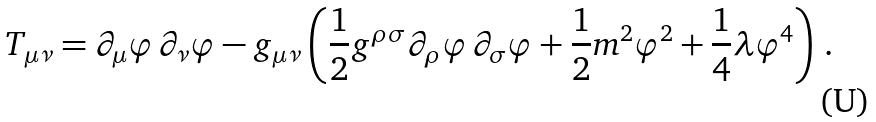<formula> <loc_0><loc_0><loc_500><loc_500>T _ { \mu \nu } = \partial _ { \mu } \varphi \, \partial _ { \nu } \varphi - g _ { \mu \nu } \left ( \frac { 1 } { 2 } g ^ { \rho \sigma } \partial _ { \rho } \varphi \, \partial _ { \sigma } \varphi + \frac { 1 } { 2 } m ^ { 2 } \varphi ^ { 2 } + \frac { 1 } { 4 } \lambda \varphi ^ { 4 } \right ) \, .</formula> 